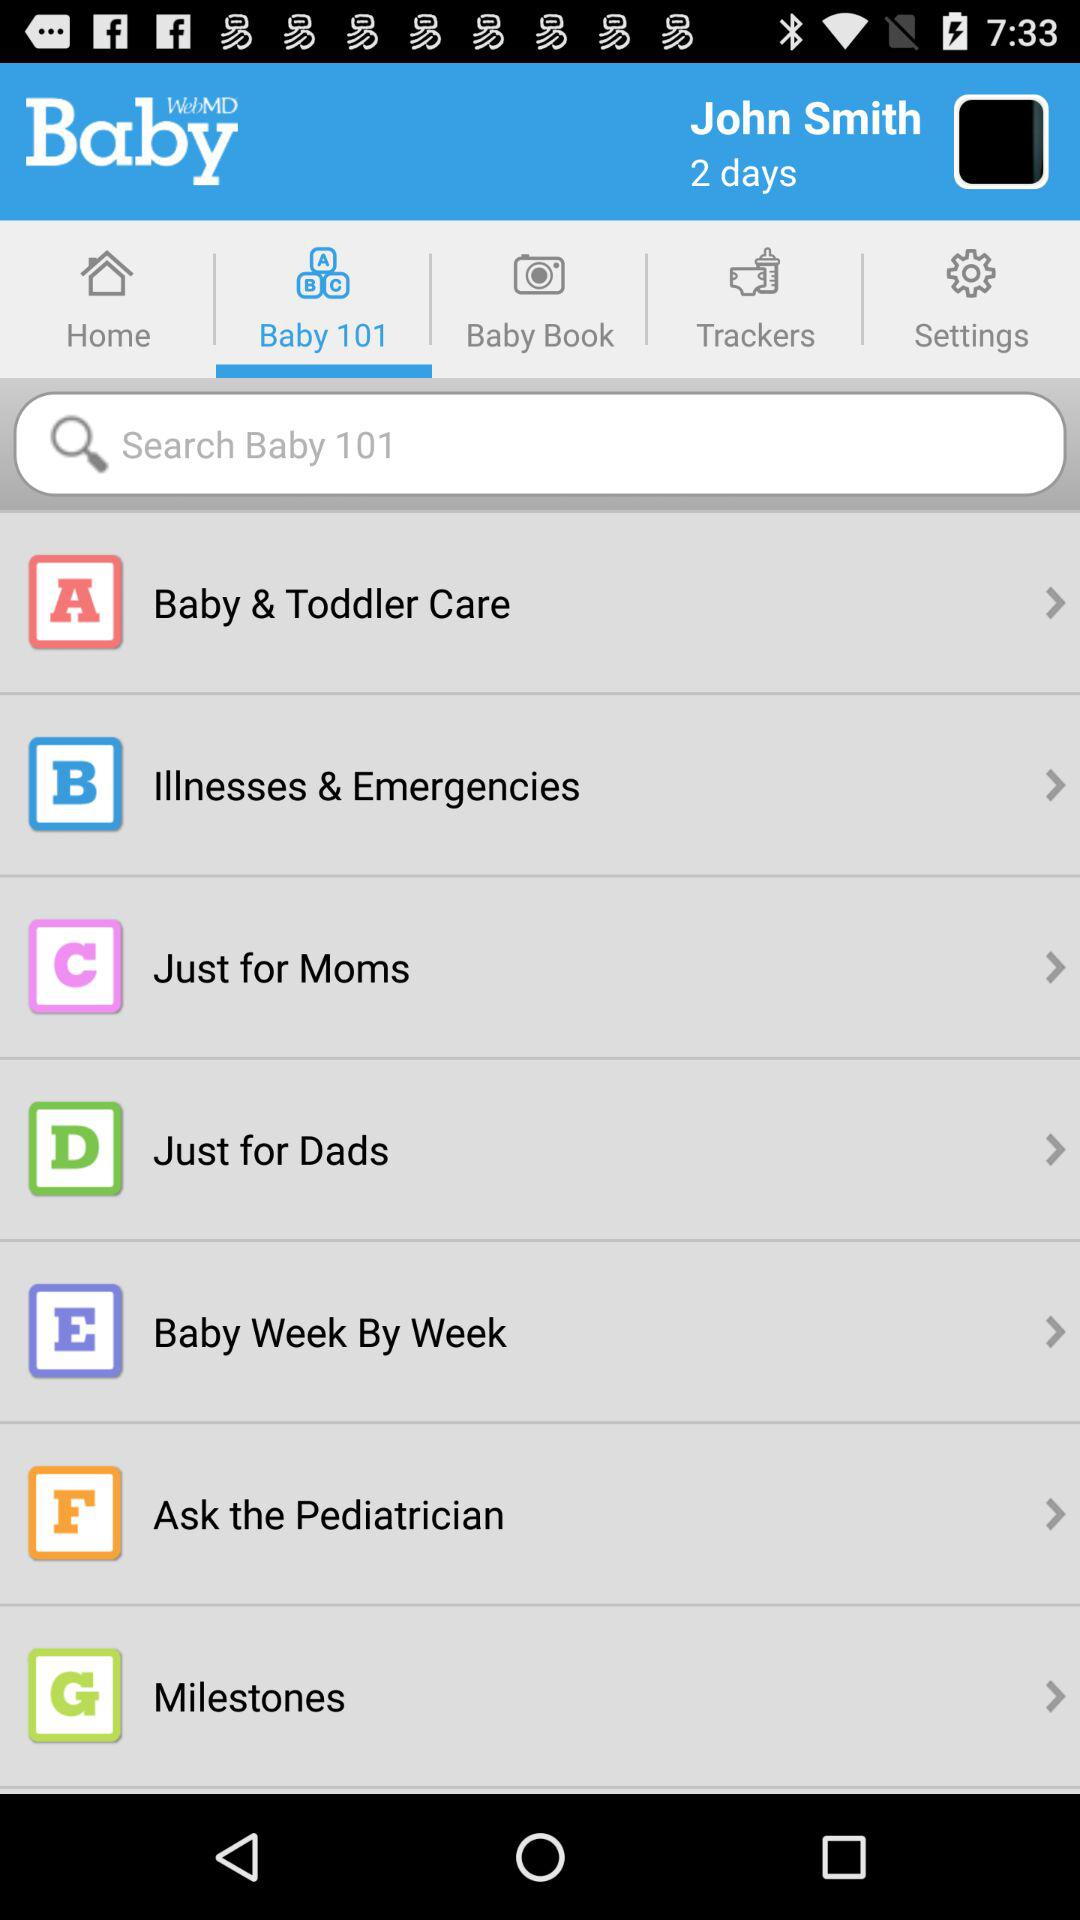What is the name of the user? The name of the user is "John Smith". 